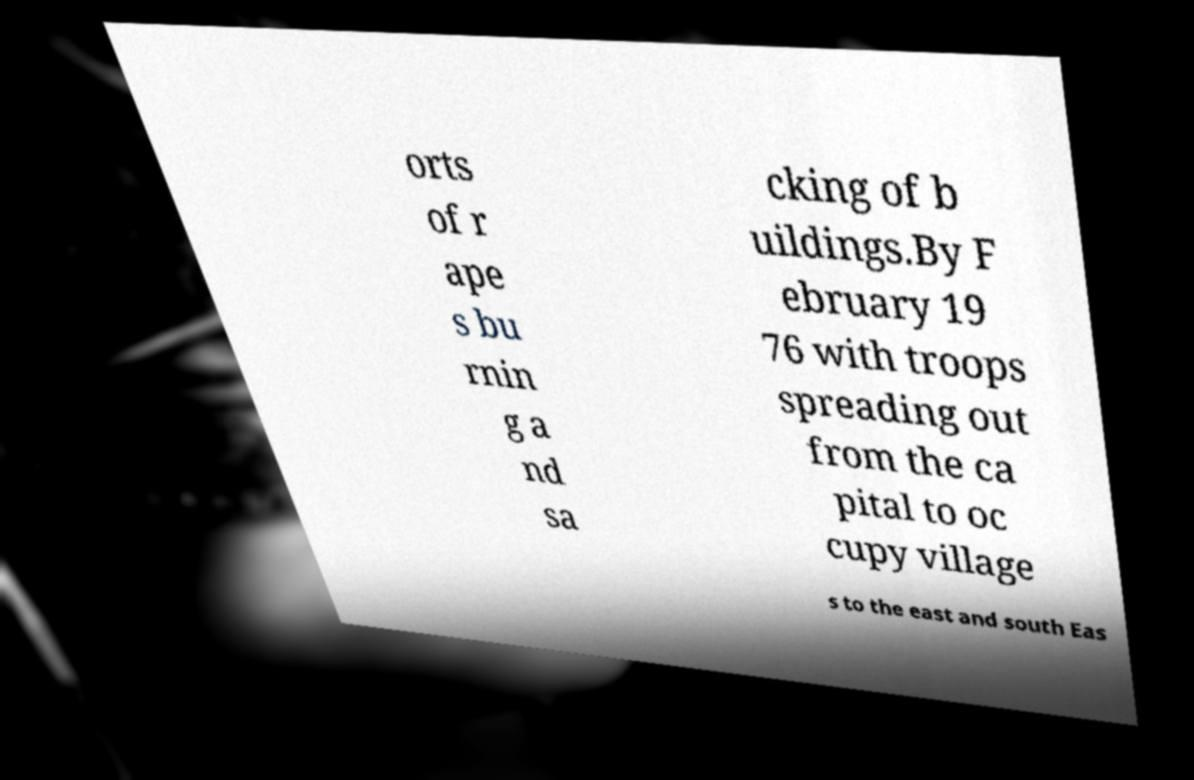Can you read and provide the text displayed in the image?This photo seems to have some interesting text. Can you extract and type it out for me? orts of r ape s bu rnin g a nd sa cking of b uildings.By F ebruary 19 76 with troops spreading out from the ca pital to oc cupy village s to the east and south Eas 